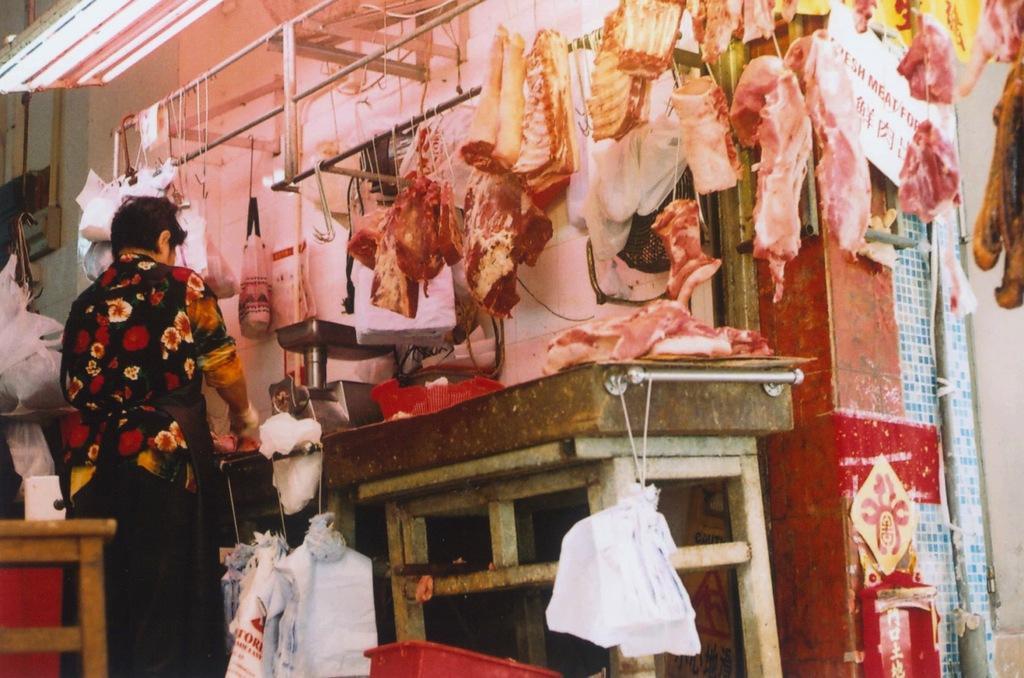Could you give a brief overview of what you see in this image? In this picture we can see the inside view of the meat shop. In the front we can see some meat pieces hanging from the top. Beside there is a man standing and cutting the meat. In the front bottom side we can see the plastic covers. 